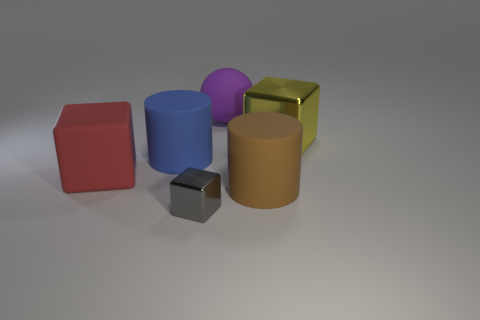Subtract all gray cylinders. Subtract all purple spheres. How many cylinders are left? 2 Add 1 large rubber cylinders. How many objects exist? 7 Subtract all balls. How many objects are left? 5 Subtract all big blue things. Subtract all green matte cylinders. How many objects are left? 5 Add 2 large blue cylinders. How many large blue cylinders are left? 3 Add 5 big gray spheres. How many big gray spheres exist? 5 Subtract 1 red cubes. How many objects are left? 5 